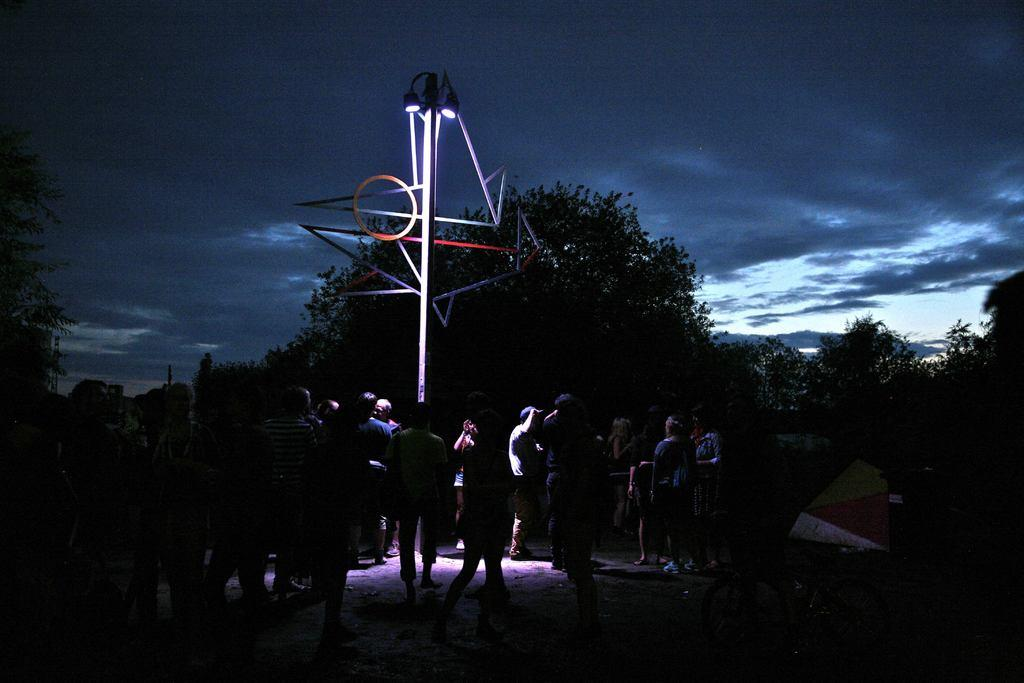What are the people in the image doing? There is a group of people standing on the ground in the image. What type of vegetation can be seen in the image? Trees are present in the image. What object can be seen in the image besides the trees and people? There is a pole in the image. What is visible in the background of the image? The sky is visible in the background of the image, and clouds are present in the sky. What type of cherries are being used to control the impulse of the people in the image? There are no cherries present in the image, and the people's impulses are not being controlled by any means. 